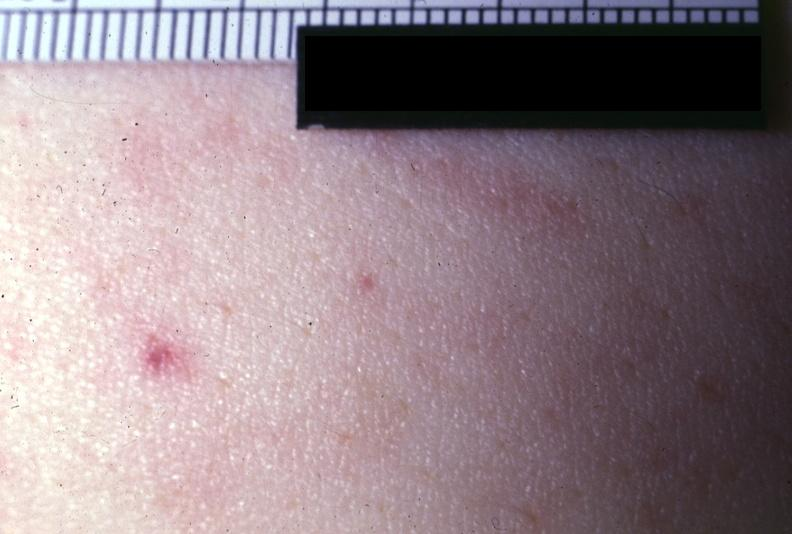does amebiasis show close-up photo very good?
Answer the question using a single word or phrase. No 